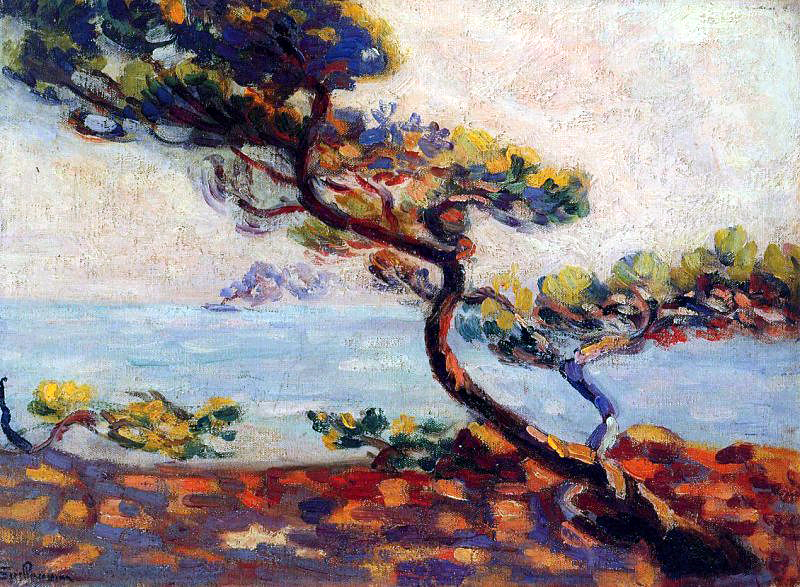If you could step into the painting, what would you do? If I could step into the painting, I would walk along the rocky shore, feeling the cool sea breeze on my face and listening to the gentle lapping of the waves. I would sit beneath the solitary tree, reflecting on its stories and the countless people who have passed by. I would spend the day capturing the beautiful colors and tranquil scene with my own brushstrokes, fully immersing myself in the serene and inspiring environment that this painting depicts. 